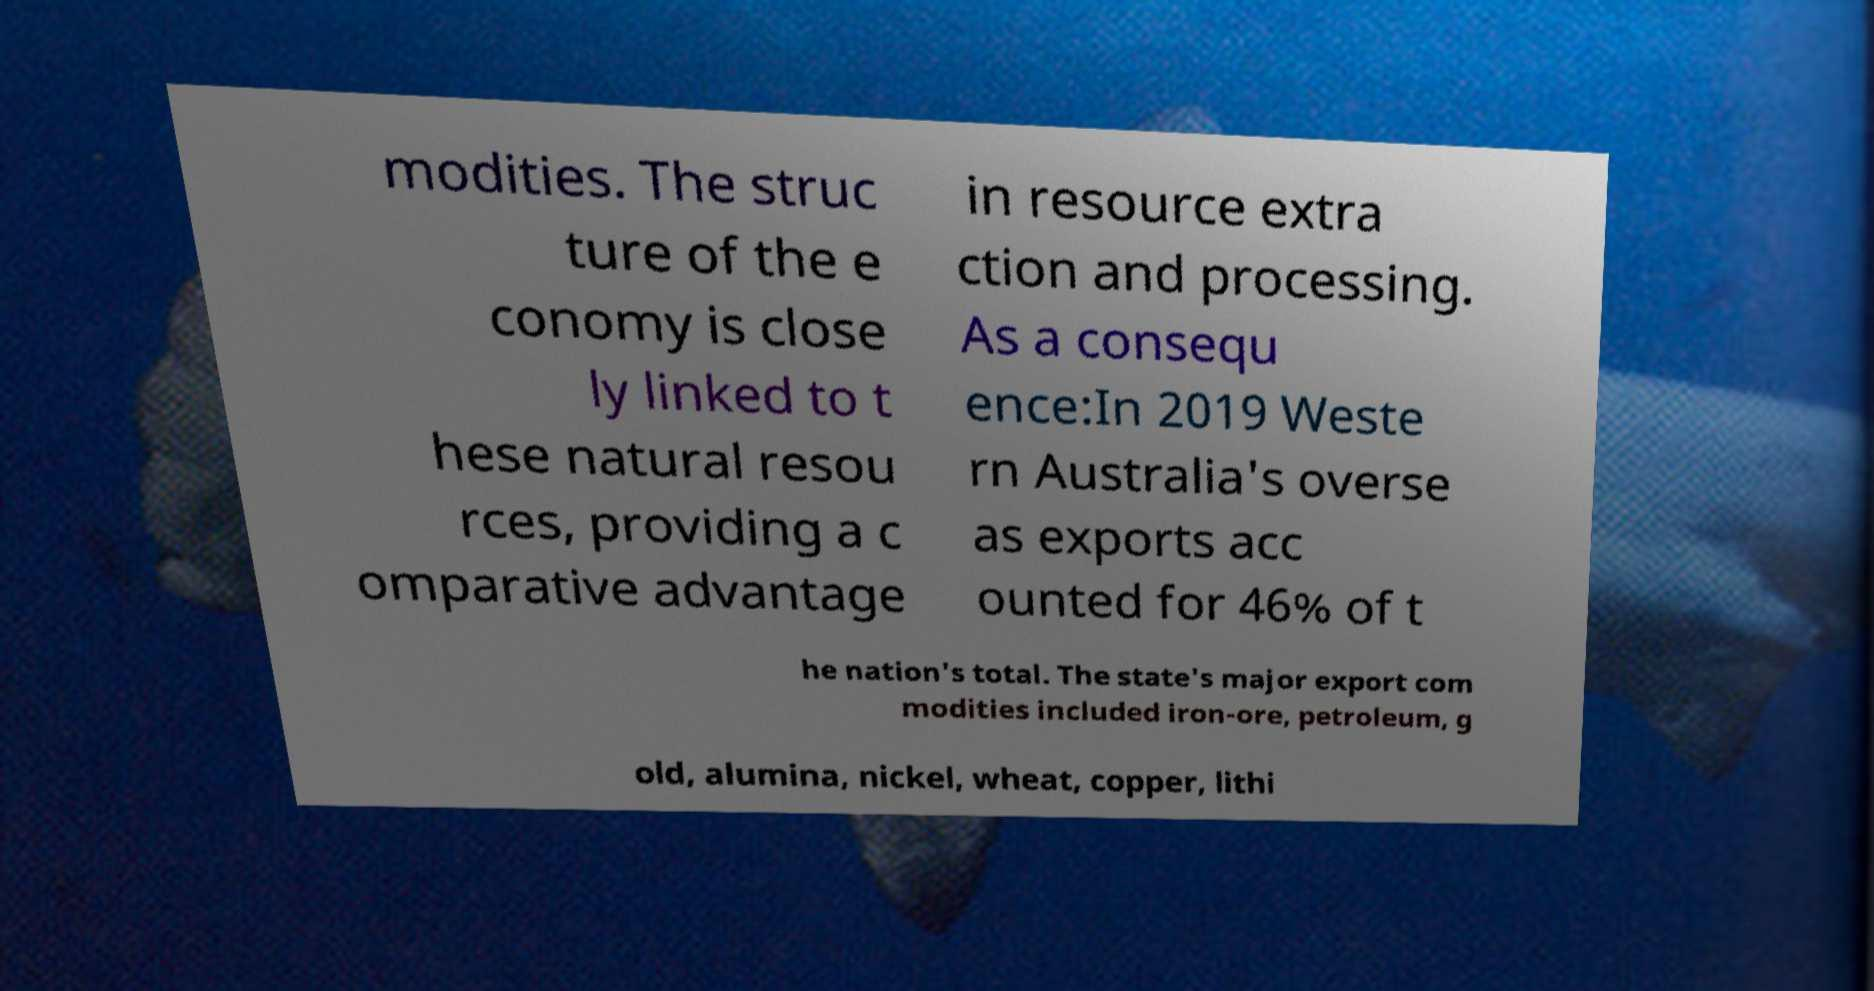Can you read and provide the text displayed in the image?This photo seems to have some interesting text. Can you extract and type it out for me? modities. The struc ture of the e conomy is close ly linked to t hese natural resou rces, providing a c omparative advantage in resource extra ction and processing. As a consequ ence:In 2019 Weste rn Australia's overse as exports acc ounted for 46% of t he nation's total. The state's major export com modities included iron-ore, petroleum, g old, alumina, nickel, wheat, copper, lithi 